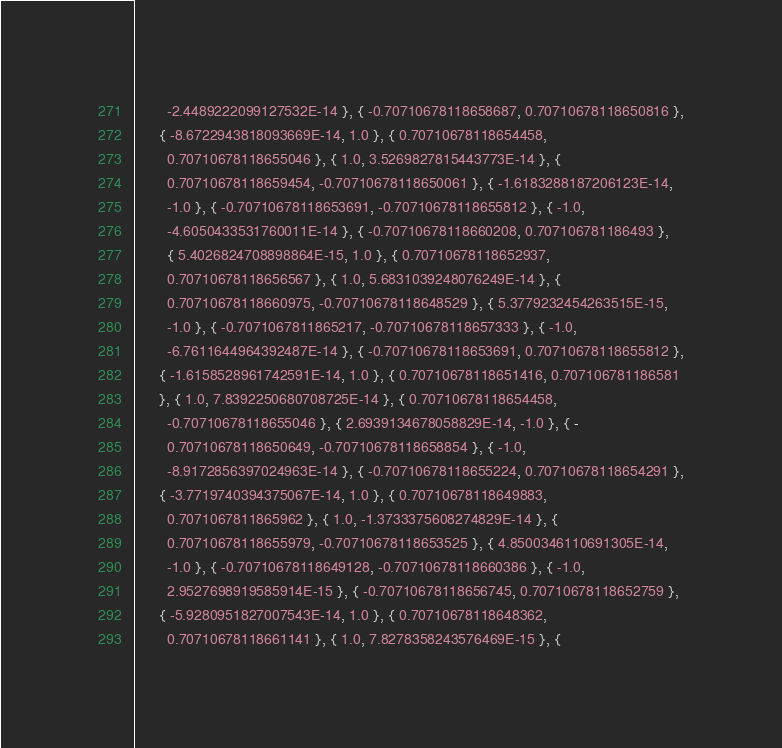Convert code to text. <code><loc_0><loc_0><loc_500><loc_500><_C_>        -2.4489222099127532E-14 }, { -0.70710678118658687, 0.70710678118650816 },
      { -8.6722943818093669E-14, 1.0 }, { 0.70710678118654458,
        0.70710678118655046 }, { 1.0, 3.5269827815443773E-14 }, {
        0.70710678118659454, -0.70710678118650061 }, { -1.6183288187206123E-14,
        -1.0 }, { -0.70710678118653691, -0.70710678118655812 }, { -1.0,
        -4.6050433531760011E-14 }, { -0.70710678118660208, 0.707106781186493 },
        { 5.4026824708898864E-15, 1.0 }, { 0.70710678118652937,
        0.70710678118656567 }, { 1.0, 5.6831039248076249E-14 }, {
        0.70710678118660975, -0.70710678118648529 }, { 5.3779232454263515E-15,
        -1.0 }, { -0.7071067811865217, -0.70710678118657333 }, { -1.0,
        -6.7611644964392487E-14 }, { -0.70710678118653691, 0.70710678118655812 },
      { -1.6158528961742591E-14, 1.0 }, { 0.70710678118651416, 0.707106781186581
      }, { 1.0, 7.8392250680708725E-14 }, { 0.70710678118654458,
        -0.70710678118655046 }, { 2.6939134678058829E-14, -1.0 }, { -
        0.70710678118650649, -0.70710678118658854 }, { -1.0,
        -8.9172856397024963E-14 }, { -0.70710678118655224, 0.70710678118654291 },
      { -3.7719740394375067E-14, 1.0 }, { 0.70710678118649883,
        0.7071067811865962 }, { 1.0, -1.3733375608274829E-14 }, {
        0.70710678118655979, -0.70710678118653525 }, { 4.8500346110691305E-14,
        -1.0 }, { -0.70710678118649128, -0.70710678118660386 }, { -1.0,
        2.9527698919585914E-15 }, { -0.70710678118656745, 0.70710678118652759 },
      { -5.9280951827007543E-14, 1.0 }, { 0.70710678118648362,
        0.70710678118661141 }, { 1.0, 7.8278358243576469E-15 }, {</code> 